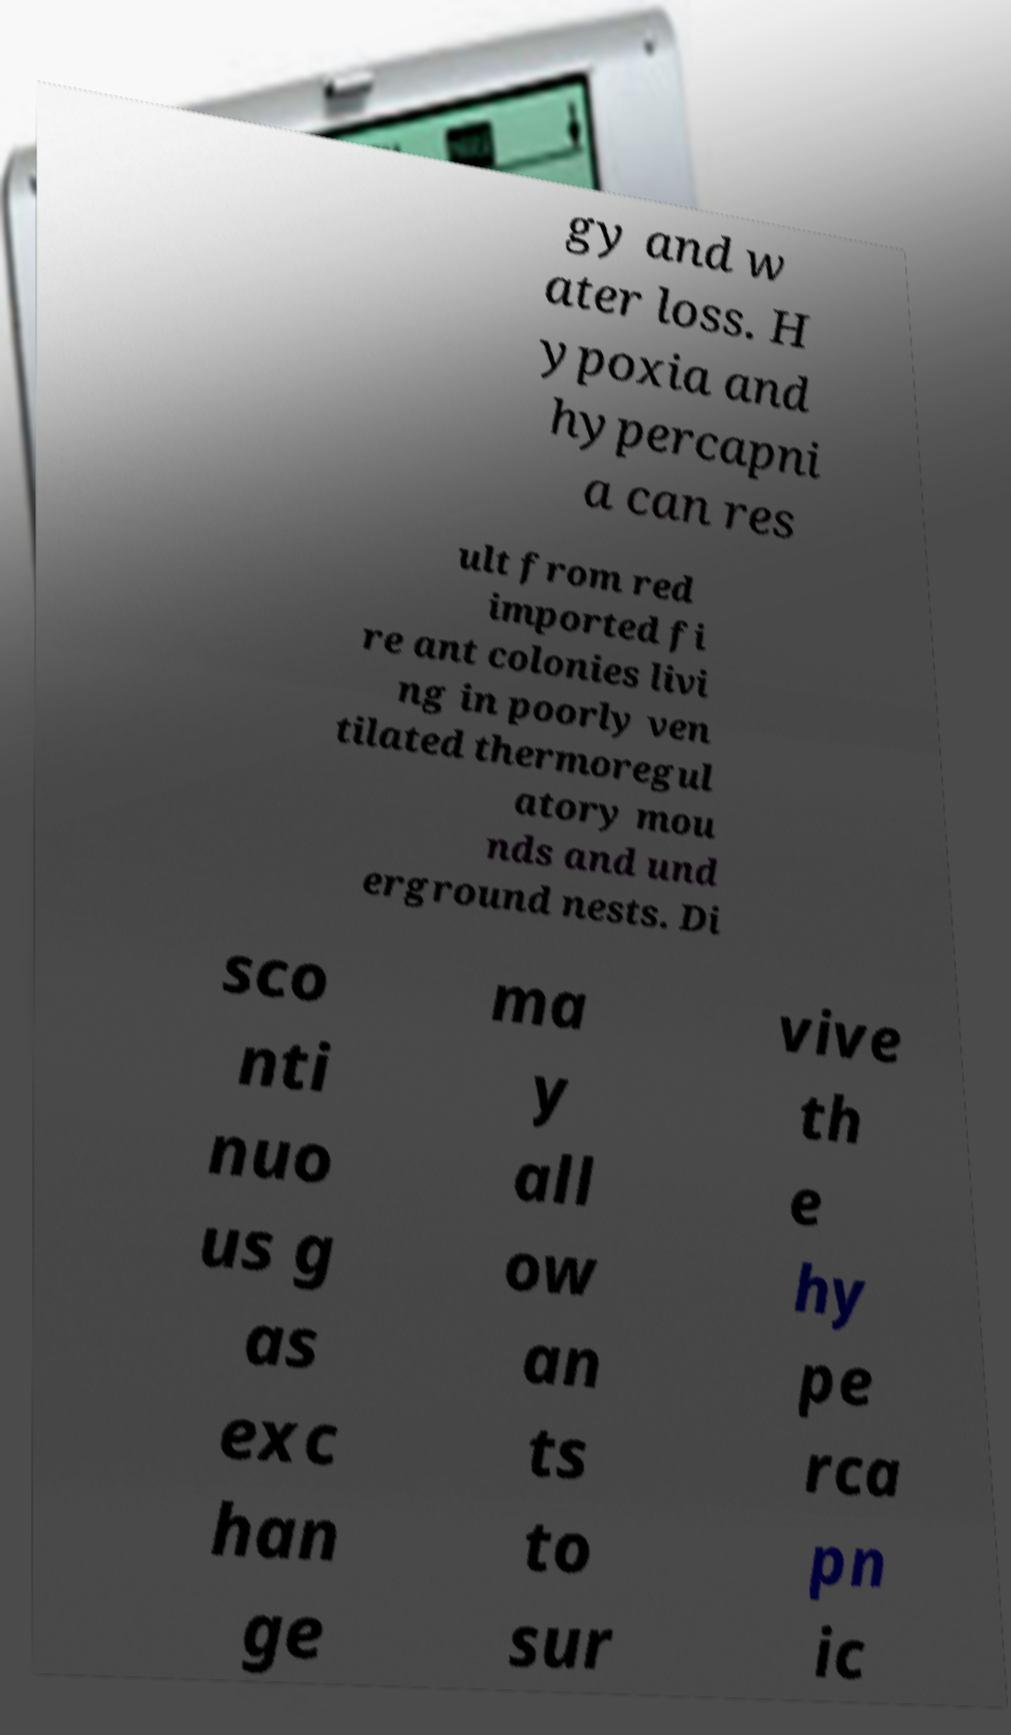Could you assist in decoding the text presented in this image and type it out clearly? gy and w ater loss. H ypoxia and hypercapni a can res ult from red imported fi re ant colonies livi ng in poorly ven tilated thermoregul atory mou nds and und erground nests. Di sco nti nuo us g as exc han ge ma y all ow an ts to sur vive th e hy pe rca pn ic 